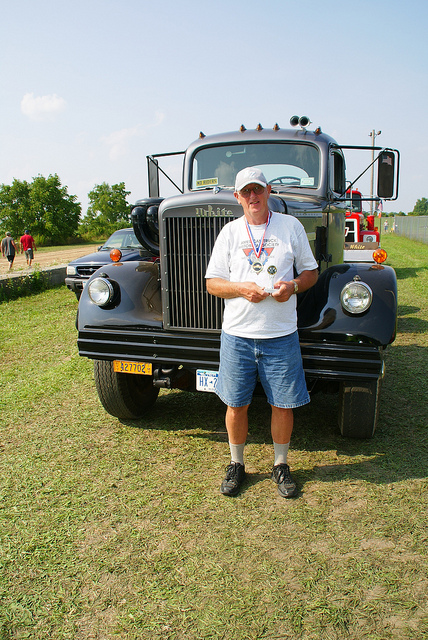Please transcribe the text information in this image. 27702 7 27702 